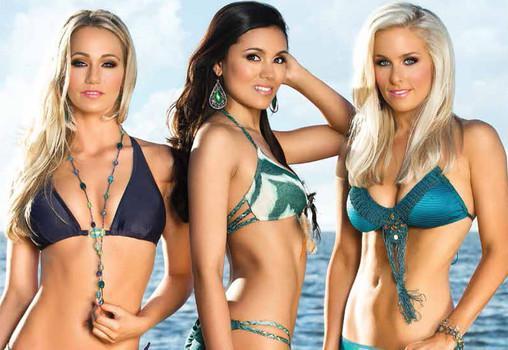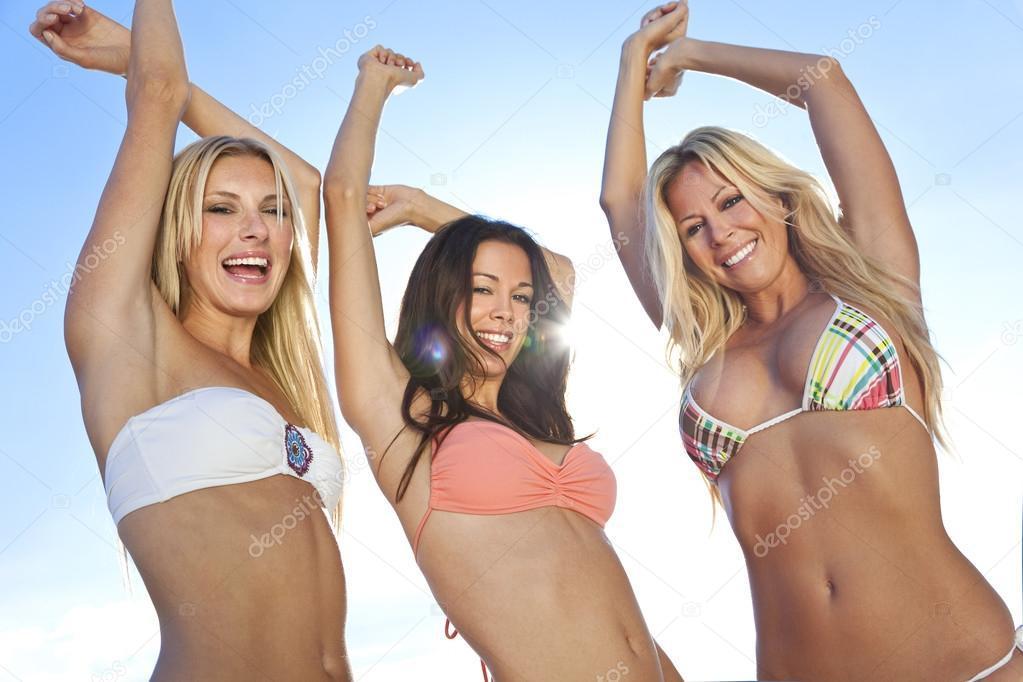The first image is the image on the left, the second image is the image on the right. Examine the images to the left and right. Is the description "Three women have their backs at the camera." accurate? Answer yes or no. No. The first image is the image on the left, the second image is the image on the right. Analyze the images presented: Is the assertion "Three models pose with rears turned to the camera in one image." valid? Answer yes or no. No. 